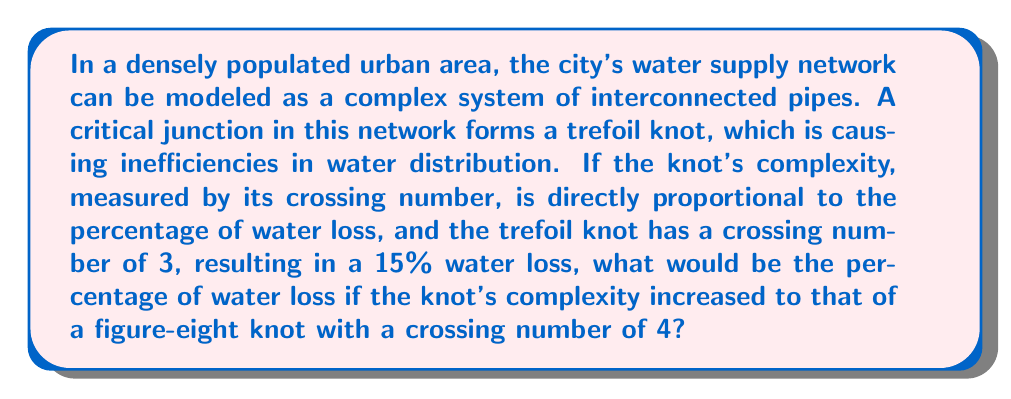Show me your answer to this math problem. To solve this problem, we need to follow these steps:

1. Understand the given information:
   - Trefoil knot crossing number: 3
   - Trefoil knot water loss: 15%
   - Figure-eight knot crossing number: 4

2. Establish the relationship between crossing number and water loss:
   Let $x$ be the crossing number and $y$ be the percentage of water loss.
   $$y = kx$$
   where $k$ is the constant of proportionality.

3. Calculate the constant of proportionality using the trefoil knot data:
   $$15 = k \cdot 3$$
   $$k = \frac{15}{3} = 5$$

4. Use this constant to calculate the water loss for the figure-eight knot:
   $$y = 5 \cdot 4 = 20$$

Therefore, the water loss percentage for the figure-eight knot would be 20%.
Answer: 20% 